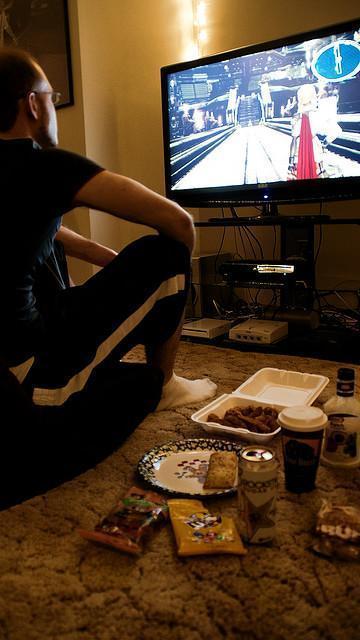How many bottles are in the picture?
Give a very brief answer. 2. How many of the chairs are blue?
Give a very brief answer. 0. 